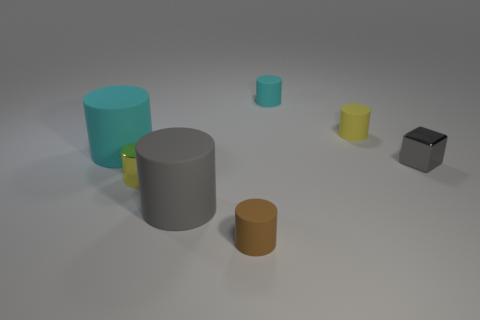Subtract all tiny metal cylinders. How many cylinders are left? 5 Subtract all brown cylinders. How many cylinders are left? 5 Subtract all blocks. How many objects are left? 6 Subtract 1 blocks. How many blocks are left? 0 Add 1 tiny green spheres. How many objects exist? 8 Subtract all gray cylinders. Subtract all red blocks. How many cylinders are left? 5 Subtract all red blocks. How many brown cylinders are left? 1 Subtract all cyan matte objects. Subtract all cyan cylinders. How many objects are left? 3 Add 7 big cyan cylinders. How many big cyan cylinders are left? 8 Add 5 large yellow rubber cylinders. How many large yellow rubber cylinders exist? 5 